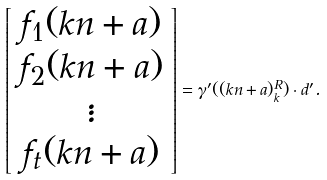<formula> <loc_0><loc_0><loc_500><loc_500>\left [ \begin{array} { c } f _ { 1 } ( k n + a ) \\ f _ { 2 } ( k n + a ) \\ \vdots \\ f _ { t } ( k n + a ) \end{array} \right ] = \gamma ^ { \prime } ( ( k n + a ) _ { k } ^ { R } ) \cdot d ^ { \prime } .</formula> 